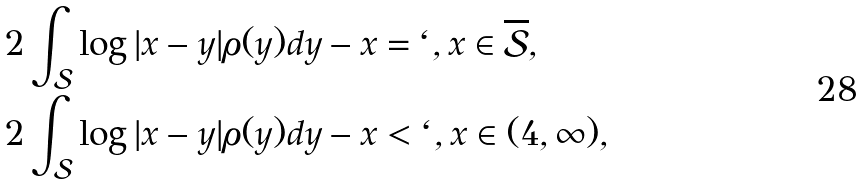Convert formula to latex. <formula><loc_0><loc_0><loc_500><loc_500>& 2 \int _ { \mathcal { S } } \log | x - y | \rho ( y ) d y - x = \ell , x \in \overline { \mathcal { S } } , \\ & 2 \int _ { \mathcal { S } } \log | x - y | \rho ( y ) d y - x < \ell , x \in ( 4 , \infty ) ,</formula> 